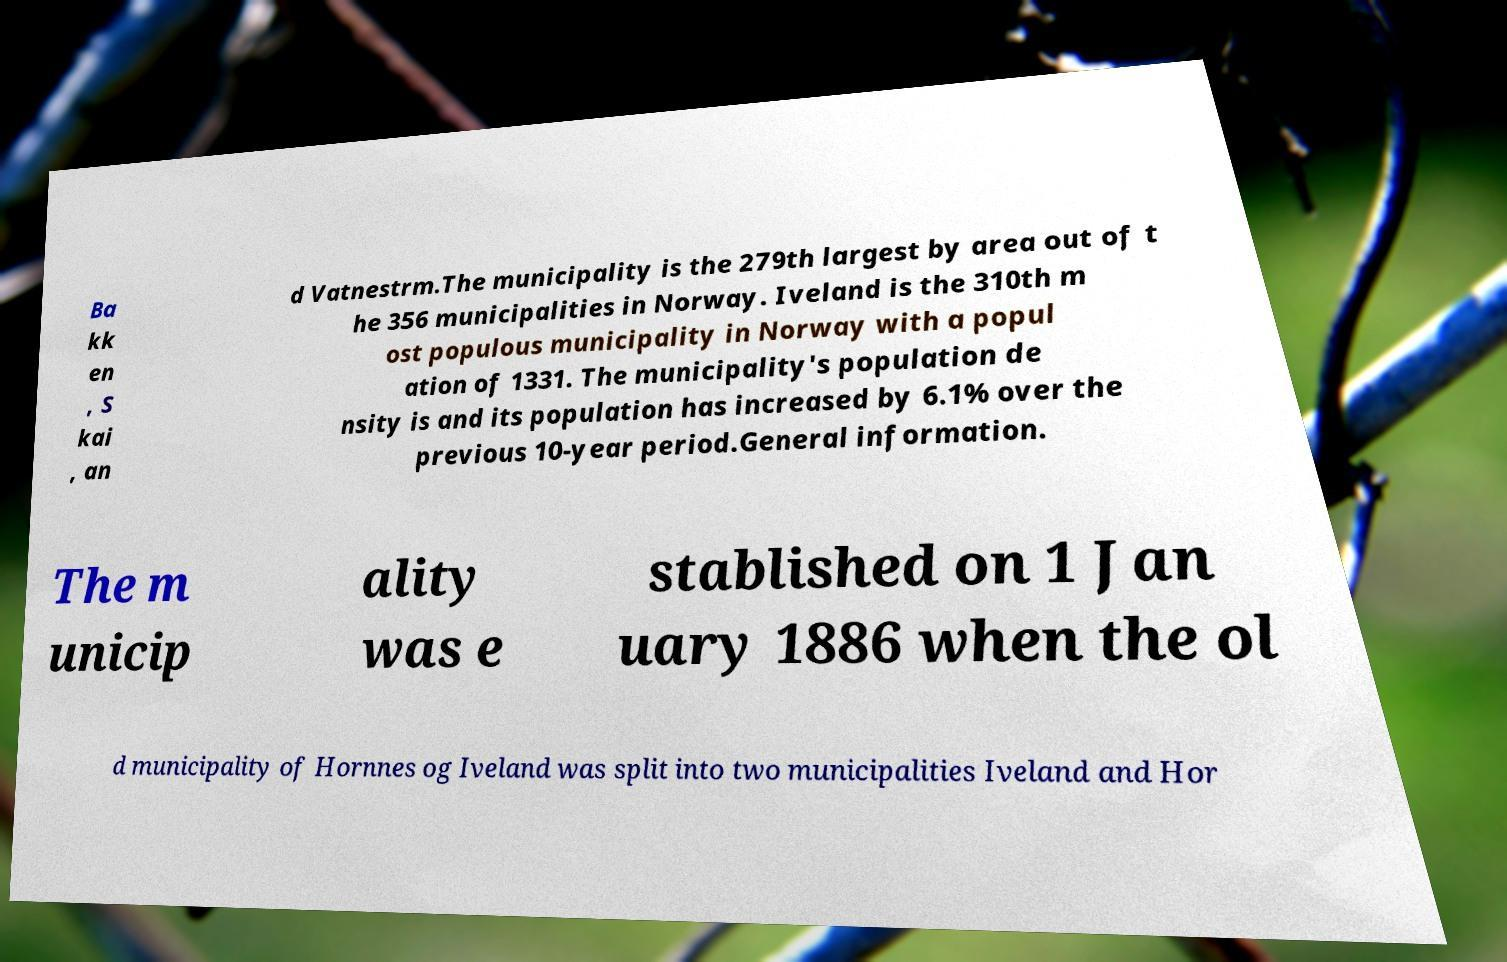Can you accurately transcribe the text from the provided image for me? Ba kk en , S kai , an d Vatnestrm.The municipality is the 279th largest by area out of t he 356 municipalities in Norway. Iveland is the 310th m ost populous municipality in Norway with a popul ation of 1331. The municipality's population de nsity is and its population has increased by 6.1% over the previous 10-year period.General information. The m unicip ality was e stablished on 1 Jan uary 1886 when the ol d municipality of Hornnes og Iveland was split into two municipalities Iveland and Hor 